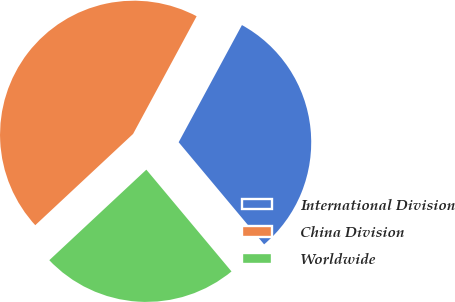<chart> <loc_0><loc_0><loc_500><loc_500><pie_chart><fcel>International Division<fcel>China Division<fcel>Worldwide<nl><fcel>31.03%<fcel>44.83%<fcel>24.14%<nl></chart> 